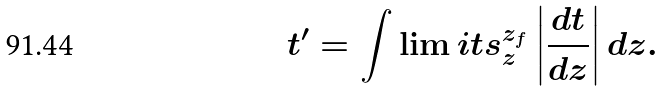<formula> <loc_0><loc_0><loc_500><loc_500>t ^ { \prime } = \int \lim i t s _ { z } ^ { z _ { f } } \left | \frac { d t } { d z } \right | d z .</formula> 